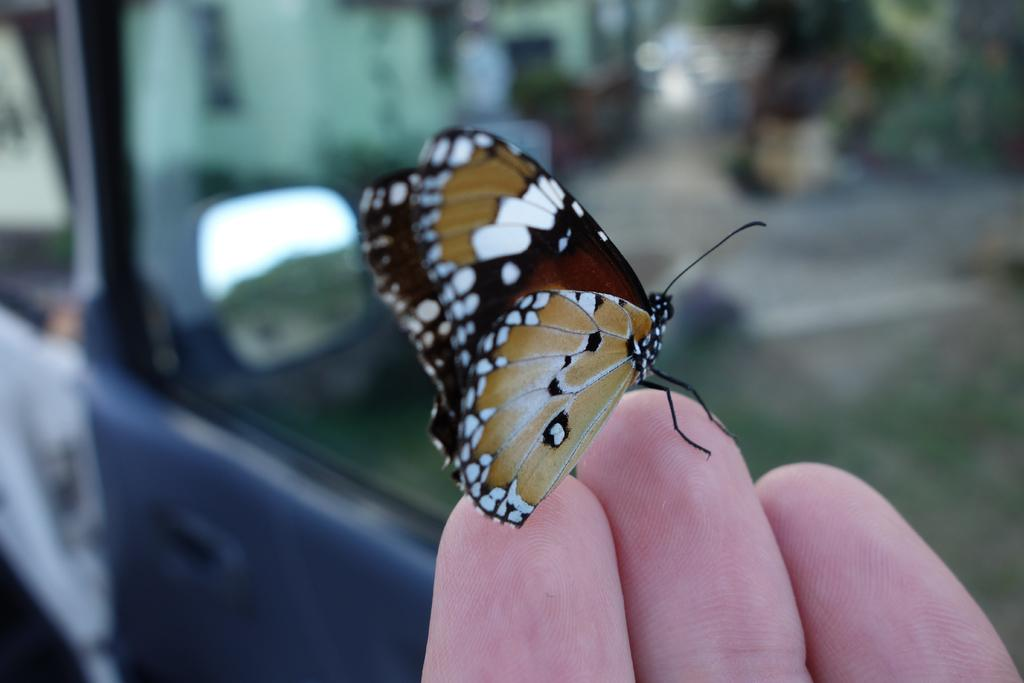What type of animal can be seen in the image? There is a butterfly in the image. What part of a person is visible in the image? Fingers of a person are visible at the bottom of the image. What can be seen in the background of the image? There appears to be a vehicle in the background of the image. What type of silk is being sold in the shop in the image? There is no shop present in the image, so it is not possible to determine if silk is being sold. 